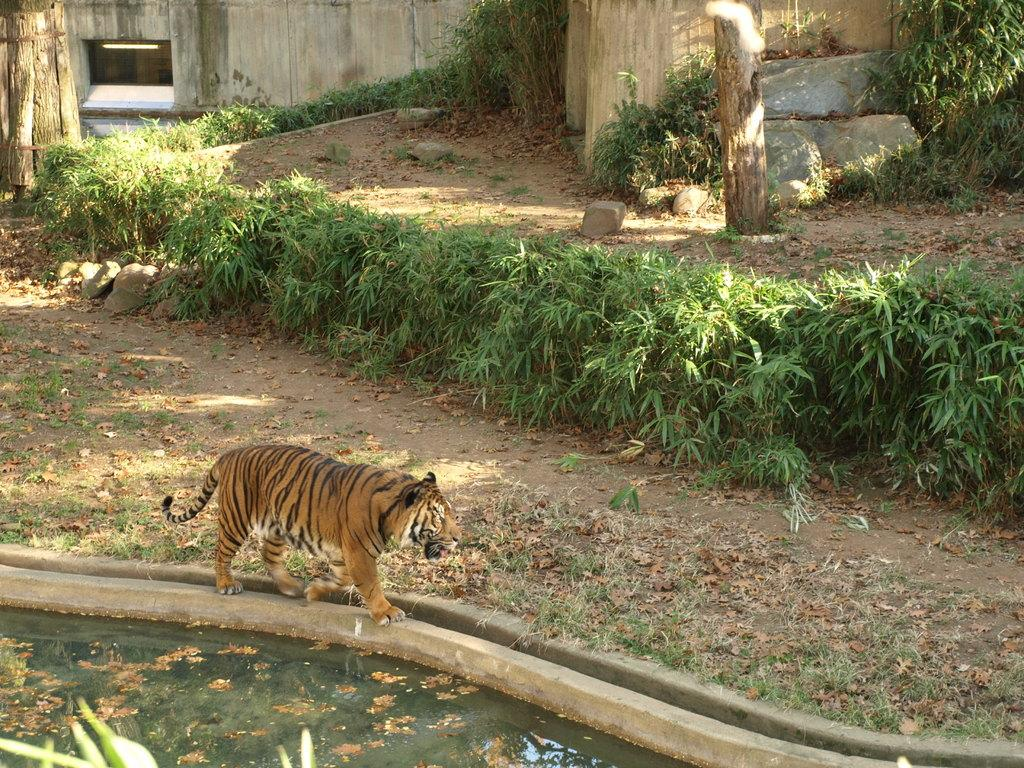What animal can be seen in the image? There is a tiger in the image. What is the tiger doing in the image? The tiger is walking. What type of environment is visible in the image? There is water, trees, and stones visible in the image. What can be seen in the background of the image? There is a wall in the background of the image. How does the tiger compare to the governor in the image? There is no governor present in the image, so it is not possible to make a comparison. 